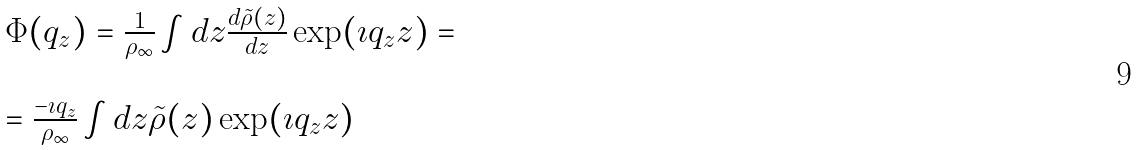Convert formula to latex. <formula><loc_0><loc_0><loc_500><loc_500>\begin{array} { l l } \Phi ( q _ { z } ) = \frac { 1 } { \rho _ { \infty } } \int d z \frac { d \tilde { \rho } ( z ) } { d z } \exp ( \imath q _ { z } z ) = \\ \\ = \frac { - \imath q _ { z } } { \rho _ { \infty } } \int d z \tilde { \rho } ( z ) \exp ( \imath q _ { z } z ) \end{array}</formula> 